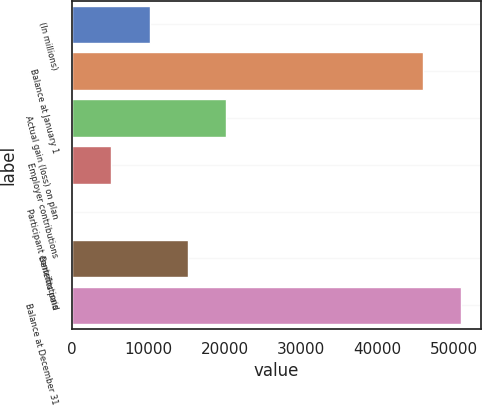Convert chart to OTSL. <chart><loc_0><loc_0><loc_500><loc_500><bar_chart><fcel>(In millions)<fcel>Balance at January 1<fcel>Actual gain (loss) on plan<fcel>Employer contributions<fcel>Participant contributions<fcel>Benefits paid<fcel>Balance at December 31<nl><fcel>10145<fcel>45893<fcel>20199<fcel>5118<fcel>91<fcel>15172<fcel>50920<nl></chart> 